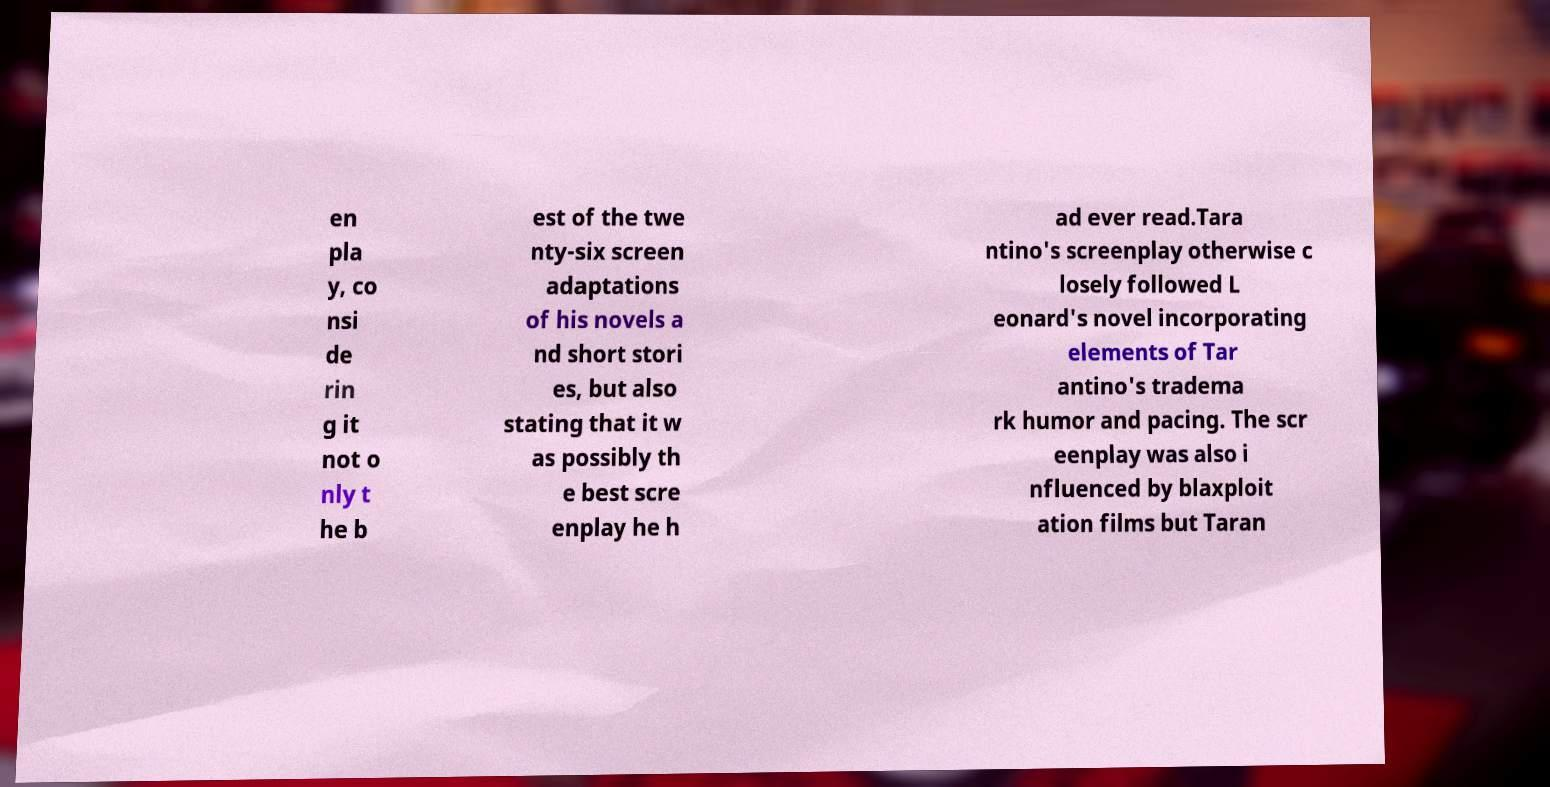Could you assist in decoding the text presented in this image and type it out clearly? en pla y, co nsi de rin g it not o nly t he b est of the twe nty-six screen adaptations of his novels a nd short stori es, but also stating that it w as possibly th e best scre enplay he h ad ever read.Tara ntino's screenplay otherwise c losely followed L eonard's novel incorporating elements of Tar antino's tradema rk humor and pacing. The scr eenplay was also i nfluenced by blaxploit ation films but Taran 